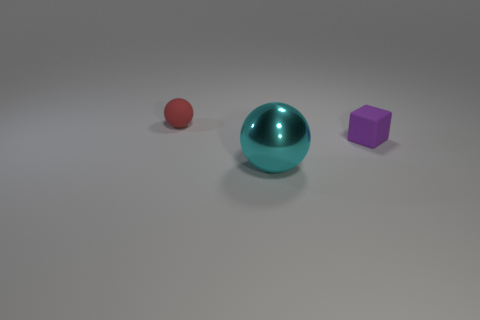Add 2 blocks. How many objects exist? 5 Subtract all blocks. How many objects are left? 2 Subtract all big cyan metal things. Subtract all tiny rubber cubes. How many objects are left? 1 Add 2 small red balls. How many small red balls are left? 3 Add 2 tiny red rubber balls. How many tiny red rubber balls exist? 3 Subtract 0 red cylinders. How many objects are left? 3 